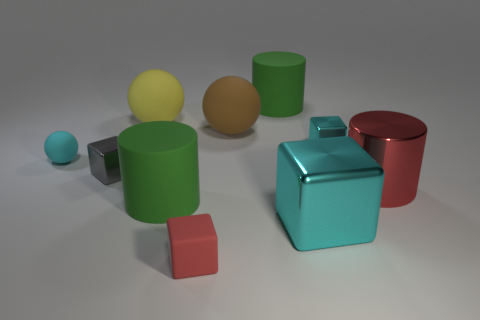Subtract all shiny cubes. How many cubes are left? 1 Subtract all gray blocks. How many blocks are left? 3 Subtract 2 cylinders. How many cylinders are left? 1 Subtract 0 blue balls. How many objects are left? 10 Subtract all cylinders. How many objects are left? 7 Subtract all brown cubes. Subtract all gray spheres. How many cubes are left? 4 Subtract all gray cylinders. How many purple spheres are left? 0 Subtract all small purple shiny cylinders. Subtract all cyan rubber balls. How many objects are left? 9 Add 7 tiny gray metallic cubes. How many tiny gray metallic cubes are left? 8 Add 2 red matte objects. How many red matte objects exist? 3 